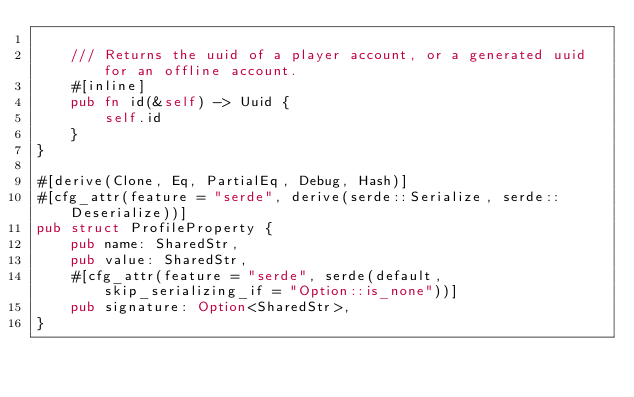Convert code to text. <code><loc_0><loc_0><loc_500><loc_500><_Rust_>
    /// Returns the uuid of a player account, or a generated uuid for an offline account.
    #[inline]
    pub fn id(&self) -> Uuid {
        self.id
    }
}

#[derive(Clone, Eq, PartialEq, Debug, Hash)]
#[cfg_attr(feature = "serde", derive(serde::Serialize, serde::Deserialize))]
pub struct ProfileProperty {
    pub name: SharedStr,
    pub value: SharedStr,
    #[cfg_attr(feature = "serde", serde(default, skip_serializing_if = "Option::is_none"))]
    pub signature: Option<SharedStr>,
}
</code> 